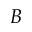<formula> <loc_0><loc_0><loc_500><loc_500>B</formula> 